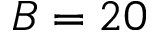<formula> <loc_0><loc_0><loc_500><loc_500>B = 2 0</formula> 